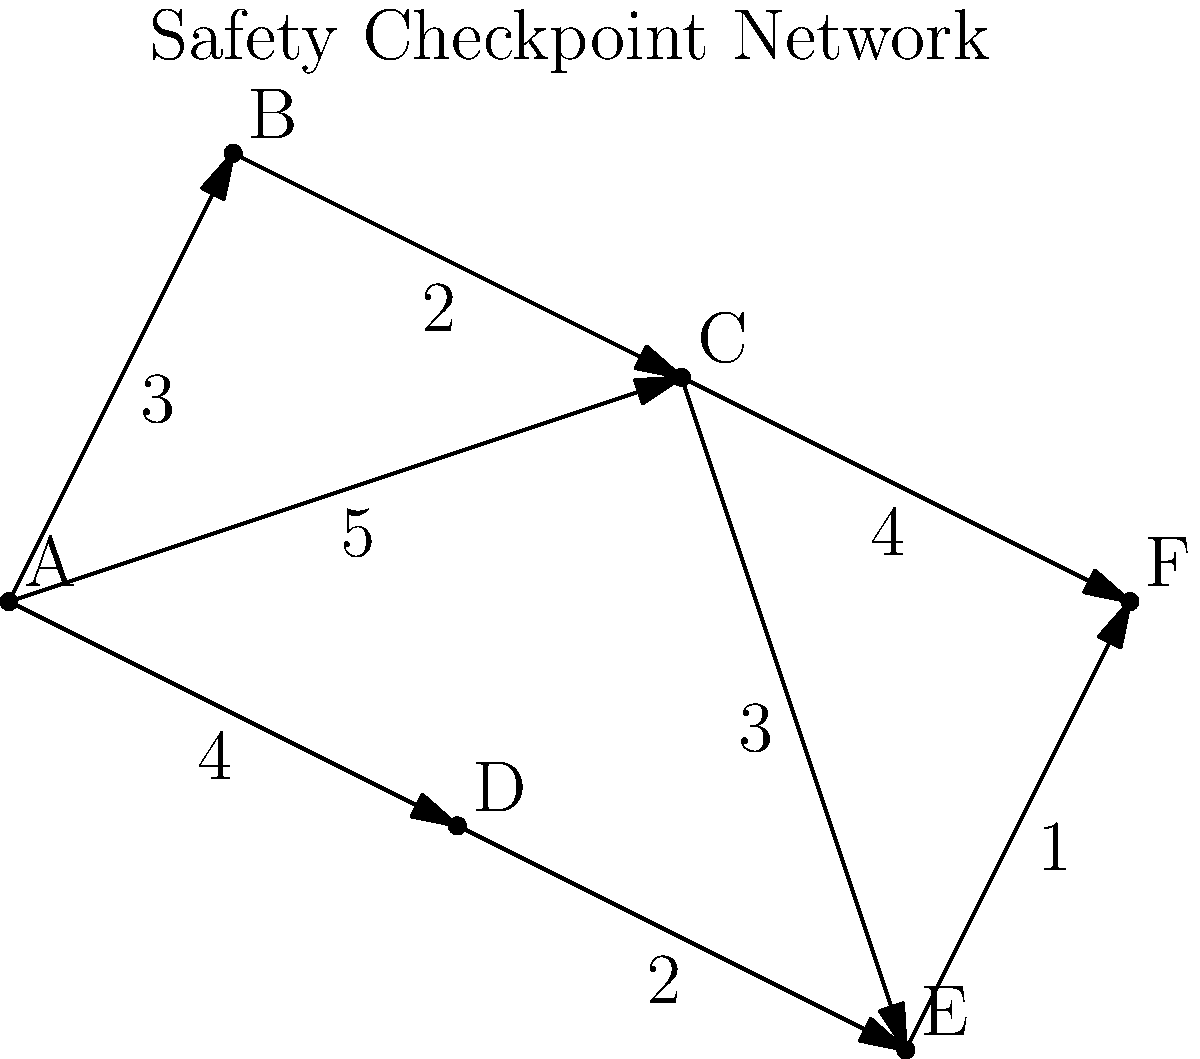As a safety compliance officer, you need to determine the shortest path through a network of safety checkpoints in a manufacturing facility. The diagram shows the network with checkpoints labeled A through F, and the numbers on the edges represent the time (in minutes) to travel between checkpoints. What is the shortest time required to travel from checkpoint A to checkpoint F? To find the shortest path from A to F, we'll use Dijkstra's algorithm:

1. Initialize:
   - Distance to A = 0
   - Distance to all other nodes = infinity
   - Set of unvisited nodes = {A, B, C, D, E, F}

2. From A, we can reach:
   - B with distance 3
   - C with distance 5
   - D with distance 4
   Update these distances and mark A as visited.

3. Select the node with the smallest distance (B, distance 3):
   - From B, we can reach C with total distance 3 + 2 = 5
   This doesn't improve C's distance, so no update. Mark B as visited.

4. Select the next smallest (D, distance 4):
   - From D, we can reach E with total distance 4 + 2 = 6
   Update E's distance to 6. Mark D as visited.

5. Select C (distance 5):
   - From C to E: 5 + 3 = 8 (not better than current 6)
   - From C to F: 5 + 4 = 9
   Update F's distance to 9. Mark C as visited.

6. Select E (distance 6):
   - From E to F: 6 + 1 = 7
   Update F's distance to 7. Mark E as visited.

7. F is the only remaining node, and its shortest distance is 7.

Therefore, the shortest path from A to F is A -> D -> E -> F, with a total time of 7 minutes.
Answer: 7 minutes 